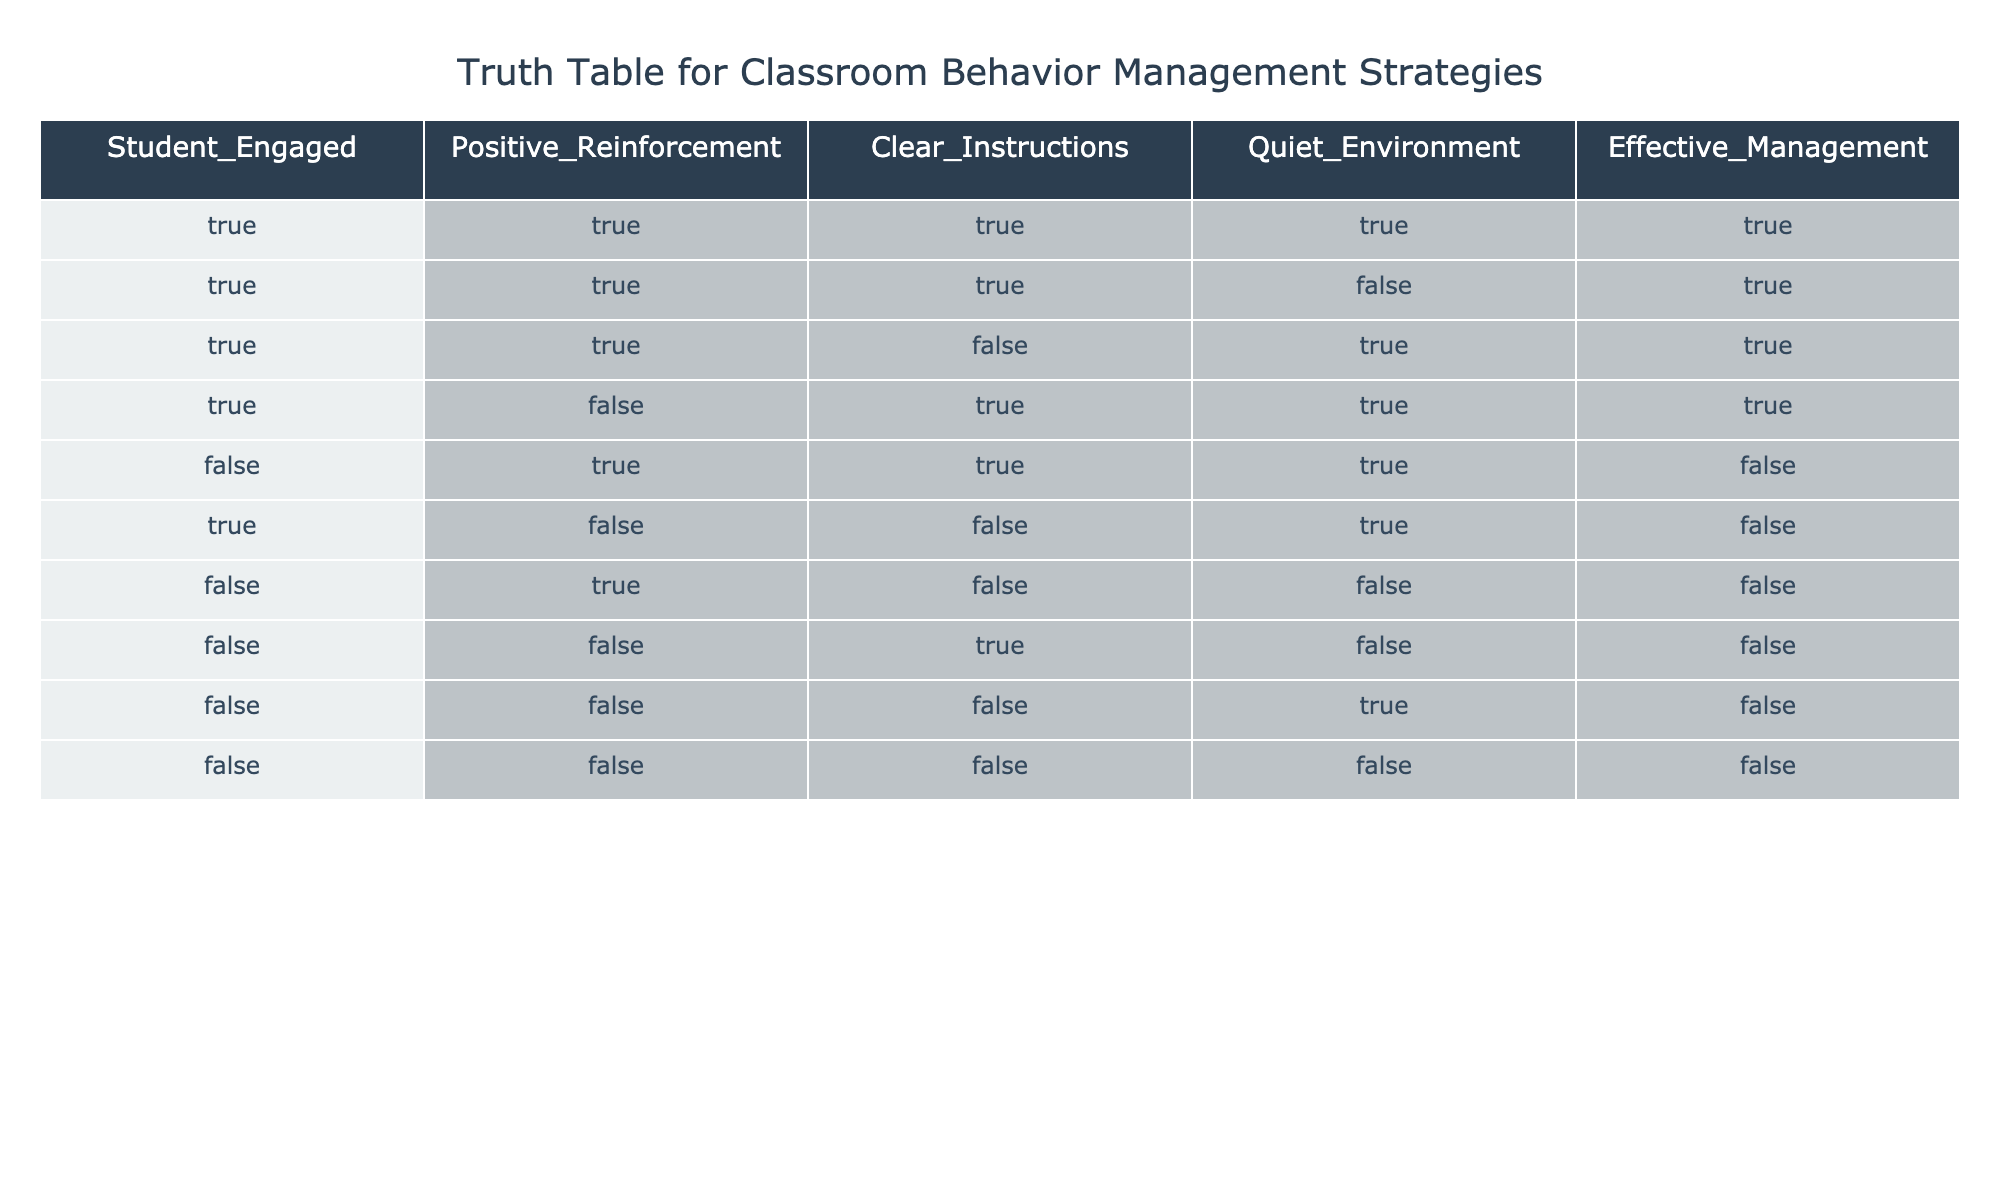What percentage of the cases had Student Engaged as TRUE? There are 10 total cases in the table. The cases where Student Engaged is TRUE are rows 1, 2, 3, and 4, which counts to 4 instances. To find the percentage, divide the number of TRUE instances by the total cases and multiply by 100: (4/10) * 100 = 40%.
Answer: 40% How many cases had Effective Management as FALSE? To find the number of cases with Effective Management as FALSE, we look at rows 5, 6, 7, 8, 9, and 10. There are 6 instances where Effective Management is FALSE.
Answer: 6 Is it true that whenever Student Engaged is TRUE, Effective Management is also TRUE? We check the rows where Student Engaged is TRUE, which are rows 1, 2, 3, and 4. Rows 1, 2, and 3 have Effective Management as TRUE, but row 4 has Effective Management as TRUE as well. Since all TRUE instances of Student Engaged correspond to Effective Management being TRUE, the statement is true.
Answer: Yes What is the total count of cases where both Positive Reinforcement and Clear Instructions are TRUE? We look for rows where both Positive Reinforcement and Clear Instructions are TRUE. The rows that meet this condition are rows 1 and 2. Thus, there are 2 cases.
Answer: 2 If a Quiet Environment is FALSE, what is the status of Student Engaged in those cases? We identify cases with Quiet Environment as FALSE, which are rows 6, 7, 8, 9, and 10. In these rows, Student Engaged is FALSE for all cases except for row 6, which is FALSE, and row 7, which is also FALSE. Therefore, in all cases of Quiet Environment being FALSE, Student Engaged is also FALSE.
Answer: FALSE 